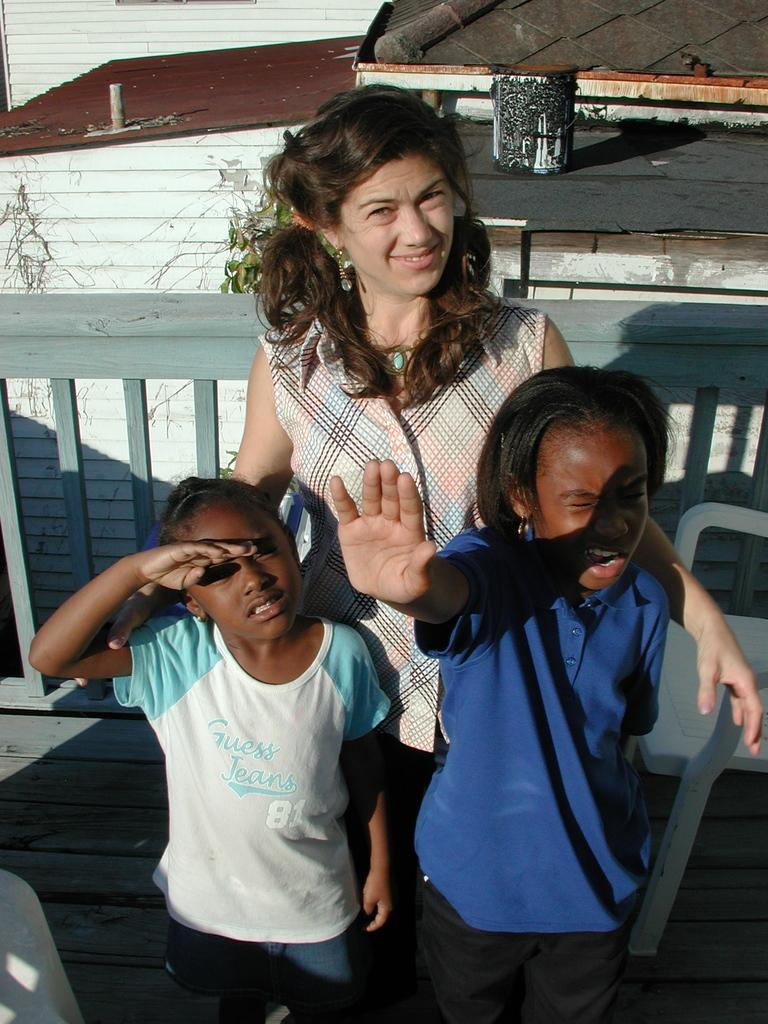What can be seen in the image regarding people? There are people standing in the image. Can you describe the attire of the people? The people are wearing different color dresses. What type of furniture is present in the image? There is a chair in the image. What kind of barrier is visible in the image? There is fencing in the image. What can be seen at the back of the image? There are objects visible at the back of the image. What type of muscle is being exercised by the people in the image? There is no indication in the image that the people are exercising or focusing on a specific muscle. 